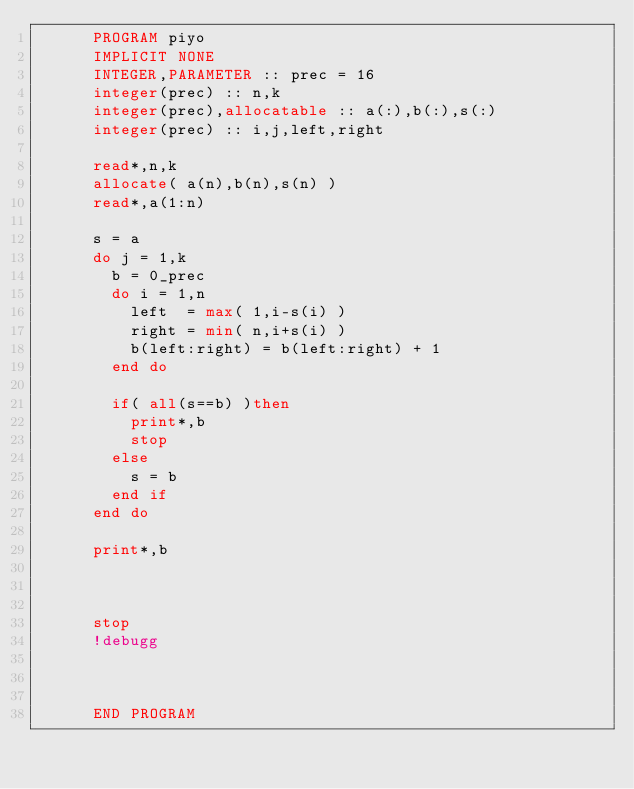Convert code to text. <code><loc_0><loc_0><loc_500><loc_500><_FORTRAN_>      PROGRAM piyo
      IMPLICIT NONE
      INTEGER,PARAMETER :: prec = 16
      integer(prec) :: n,k
      integer(prec),allocatable :: a(:),b(:),s(:)
      integer(prec) :: i,j,left,right
      
      read*,n,k
      allocate( a(n),b(n),s(n) )
      read*,a(1:n)
      
      s = a
      do j = 1,k
        b = 0_prec
        do i = 1,n
          left  = max( 1,i-s(i) )
          right = min( n,i+s(i) )
          b(left:right) = b(left:right) + 1
        end do
        
        if( all(s==b) )then
          print*,b
          stop
        else
          s = b
        end if
      end do
      
      print*,b 
      
      
      
      stop
      !debugg
      
      
      
      END PROGRAM</code> 